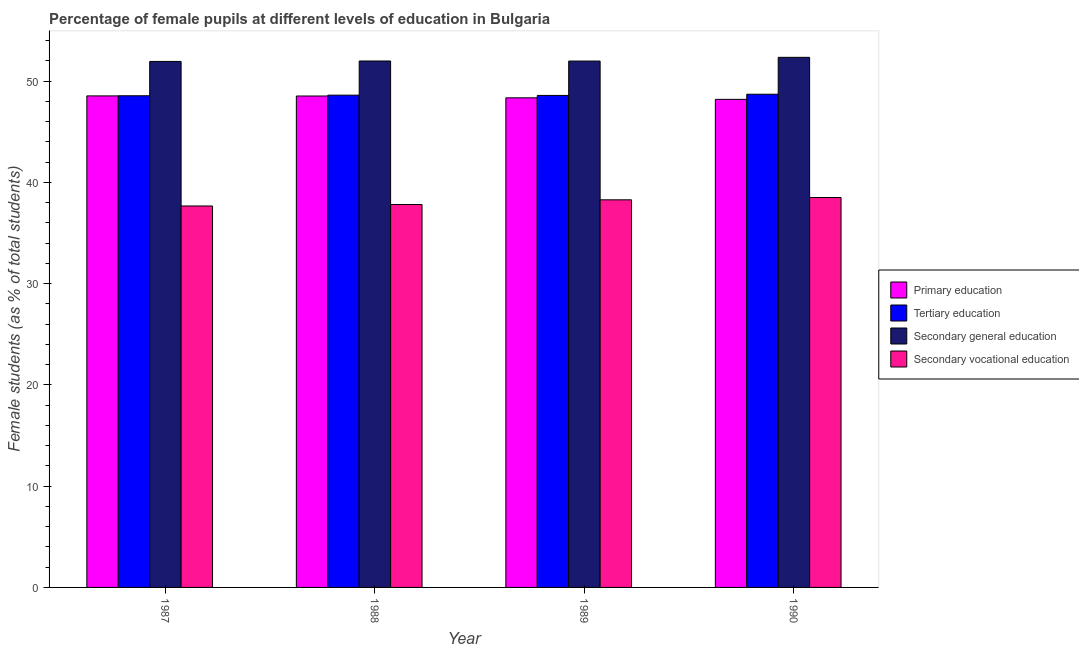How many different coloured bars are there?
Provide a succinct answer. 4. How many groups of bars are there?
Your response must be concise. 4. Are the number of bars per tick equal to the number of legend labels?
Your answer should be compact. Yes. How many bars are there on the 1st tick from the left?
Keep it short and to the point. 4. What is the percentage of female students in tertiary education in 1989?
Your answer should be compact. 48.58. Across all years, what is the maximum percentage of female students in secondary vocational education?
Offer a very short reply. 38.5. Across all years, what is the minimum percentage of female students in tertiary education?
Ensure brevity in your answer.  48.55. In which year was the percentage of female students in tertiary education maximum?
Your answer should be compact. 1990. What is the total percentage of female students in primary education in the graph?
Keep it short and to the point. 193.59. What is the difference between the percentage of female students in primary education in 1987 and that in 1990?
Provide a succinct answer. 0.34. What is the difference between the percentage of female students in tertiary education in 1990 and the percentage of female students in secondary vocational education in 1987?
Your answer should be compact. 0.15. What is the average percentage of female students in secondary education per year?
Your response must be concise. 52.06. In how many years, is the percentage of female students in secondary education greater than 2 %?
Your answer should be compact. 4. What is the ratio of the percentage of female students in tertiary education in 1989 to that in 1990?
Your response must be concise. 1. Is the percentage of female students in tertiary education in 1988 less than that in 1989?
Your answer should be compact. No. Is the difference between the percentage of female students in secondary vocational education in 1989 and 1990 greater than the difference between the percentage of female students in primary education in 1989 and 1990?
Ensure brevity in your answer.  No. What is the difference between the highest and the second highest percentage of female students in primary education?
Your answer should be very brief. 0.01. What is the difference between the highest and the lowest percentage of female students in secondary vocational education?
Make the answer very short. 0.84. Is the sum of the percentage of female students in primary education in 1988 and 1990 greater than the maximum percentage of female students in tertiary education across all years?
Offer a very short reply. Yes. Is it the case that in every year, the sum of the percentage of female students in primary education and percentage of female students in secondary vocational education is greater than the sum of percentage of female students in secondary education and percentage of female students in tertiary education?
Provide a succinct answer. Yes. What does the 1st bar from the left in 1988 represents?
Ensure brevity in your answer.  Primary education. What does the 2nd bar from the right in 1990 represents?
Your answer should be very brief. Secondary general education. How many years are there in the graph?
Provide a short and direct response. 4. Does the graph contain any zero values?
Ensure brevity in your answer.  No. Does the graph contain grids?
Offer a very short reply. No. Where does the legend appear in the graph?
Provide a succinct answer. Center right. How are the legend labels stacked?
Ensure brevity in your answer.  Vertical. What is the title of the graph?
Provide a short and direct response. Percentage of female pupils at different levels of education in Bulgaria. What is the label or title of the Y-axis?
Keep it short and to the point. Female students (as % of total students). What is the Female students (as % of total students) of Primary education in 1987?
Keep it short and to the point. 48.53. What is the Female students (as % of total students) in Tertiary education in 1987?
Ensure brevity in your answer.  48.55. What is the Female students (as % of total students) in Secondary general education in 1987?
Provide a succinct answer. 51.94. What is the Female students (as % of total students) in Secondary vocational education in 1987?
Ensure brevity in your answer.  37.66. What is the Female students (as % of total students) of Primary education in 1988?
Your response must be concise. 48.52. What is the Female students (as % of total students) in Tertiary education in 1988?
Make the answer very short. 48.6. What is the Female students (as % of total students) of Secondary general education in 1988?
Offer a very short reply. 51.98. What is the Female students (as % of total students) in Secondary vocational education in 1988?
Your response must be concise. 37.81. What is the Female students (as % of total students) of Primary education in 1989?
Offer a very short reply. 48.34. What is the Female students (as % of total students) of Tertiary education in 1989?
Make the answer very short. 48.58. What is the Female students (as % of total students) in Secondary general education in 1989?
Provide a short and direct response. 51.97. What is the Female students (as % of total students) in Secondary vocational education in 1989?
Offer a terse response. 38.27. What is the Female students (as % of total students) in Primary education in 1990?
Make the answer very short. 48.19. What is the Female students (as % of total students) in Tertiary education in 1990?
Keep it short and to the point. 48.7. What is the Female students (as % of total students) of Secondary general education in 1990?
Keep it short and to the point. 52.34. What is the Female students (as % of total students) in Secondary vocational education in 1990?
Your answer should be compact. 38.5. Across all years, what is the maximum Female students (as % of total students) of Primary education?
Provide a succinct answer. 48.53. Across all years, what is the maximum Female students (as % of total students) in Tertiary education?
Your response must be concise. 48.7. Across all years, what is the maximum Female students (as % of total students) of Secondary general education?
Your answer should be compact. 52.34. Across all years, what is the maximum Female students (as % of total students) of Secondary vocational education?
Your response must be concise. 38.5. Across all years, what is the minimum Female students (as % of total students) of Primary education?
Provide a short and direct response. 48.19. Across all years, what is the minimum Female students (as % of total students) of Tertiary education?
Provide a short and direct response. 48.55. Across all years, what is the minimum Female students (as % of total students) of Secondary general education?
Your answer should be compact. 51.94. Across all years, what is the minimum Female students (as % of total students) in Secondary vocational education?
Offer a terse response. 37.66. What is the total Female students (as % of total students) of Primary education in the graph?
Offer a very short reply. 193.59. What is the total Female students (as % of total students) in Tertiary education in the graph?
Offer a terse response. 194.43. What is the total Female students (as % of total students) of Secondary general education in the graph?
Give a very brief answer. 208.23. What is the total Female students (as % of total students) in Secondary vocational education in the graph?
Your response must be concise. 152.24. What is the difference between the Female students (as % of total students) of Primary education in 1987 and that in 1988?
Give a very brief answer. 0.01. What is the difference between the Female students (as % of total students) in Tertiary education in 1987 and that in 1988?
Keep it short and to the point. -0.06. What is the difference between the Female students (as % of total students) of Secondary general education in 1987 and that in 1988?
Offer a terse response. -0.04. What is the difference between the Female students (as % of total students) in Secondary vocational education in 1987 and that in 1988?
Offer a terse response. -0.15. What is the difference between the Female students (as % of total students) in Primary education in 1987 and that in 1989?
Your answer should be compact. 0.19. What is the difference between the Female students (as % of total students) in Tertiary education in 1987 and that in 1989?
Your response must be concise. -0.03. What is the difference between the Female students (as % of total students) in Secondary general education in 1987 and that in 1989?
Keep it short and to the point. -0.04. What is the difference between the Female students (as % of total students) in Secondary vocational education in 1987 and that in 1989?
Ensure brevity in your answer.  -0.61. What is the difference between the Female students (as % of total students) of Primary education in 1987 and that in 1990?
Your answer should be compact. 0.34. What is the difference between the Female students (as % of total students) of Tertiary education in 1987 and that in 1990?
Keep it short and to the point. -0.15. What is the difference between the Female students (as % of total students) in Secondary general education in 1987 and that in 1990?
Your answer should be very brief. -0.4. What is the difference between the Female students (as % of total students) of Secondary vocational education in 1987 and that in 1990?
Offer a very short reply. -0.84. What is the difference between the Female students (as % of total students) in Primary education in 1988 and that in 1989?
Make the answer very short. 0.18. What is the difference between the Female students (as % of total students) in Tertiary education in 1988 and that in 1989?
Your response must be concise. 0.03. What is the difference between the Female students (as % of total students) in Secondary general education in 1988 and that in 1989?
Offer a very short reply. 0.01. What is the difference between the Female students (as % of total students) in Secondary vocational education in 1988 and that in 1989?
Offer a terse response. -0.46. What is the difference between the Female students (as % of total students) of Primary education in 1988 and that in 1990?
Give a very brief answer. 0.33. What is the difference between the Female students (as % of total students) of Tertiary education in 1988 and that in 1990?
Provide a succinct answer. -0.09. What is the difference between the Female students (as % of total students) in Secondary general education in 1988 and that in 1990?
Ensure brevity in your answer.  -0.36. What is the difference between the Female students (as % of total students) of Secondary vocational education in 1988 and that in 1990?
Give a very brief answer. -0.69. What is the difference between the Female students (as % of total students) in Primary education in 1989 and that in 1990?
Provide a succinct answer. 0.15. What is the difference between the Female students (as % of total students) of Tertiary education in 1989 and that in 1990?
Keep it short and to the point. -0.12. What is the difference between the Female students (as % of total students) of Secondary general education in 1989 and that in 1990?
Your response must be concise. -0.37. What is the difference between the Female students (as % of total students) in Secondary vocational education in 1989 and that in 1990?
Provide a succinct answer. -0.23. What is the difference between the Female students (as % of total students) in Primary education in 1987 and the Female students (as % of total students) in Tertiary education in 1988?
Provide a succinct answer. -0.07. What is the difference between the Female students (as % of total students) in Primary education in 1987 and the Female students (as % of total students) in Secondary general education in 1988?
Offer a very short reply. -3.45. What is the difference between the Female students (as % of total students) of Primary education in 1987 and the Female students (as % of total students) of Secondary vocational education in 1988?
Your answer should be compact. 10.72. What is the difference between the Female students (as % of total students) of Tertiary education in 1987 and the Female students (as % of total students) of Secondary general education in 1988?
Keep it short and to the point. -3.43. What is the difference between the Female students (as % of total students) in Tertiary education in 1987 and the Female students (as % of total students) in Secondary vocational education in 1988?
Offer a very short reply. 10.74. What is the difference between the Female students (as % of total students) of Secondary general education in 1987 and the Female students (as % of total students) of Secondary vocational education in 1988?
Your answer should be compact. 14.13. What is the difference between the Female students (as % of total students) of Primary education in 1987 and the Female students (as % of total students) of Tertiary education in 1989?
Ensure brevity in your answer.  -0.05. What is the difference between the Female students (as % of total students) of Primary education in 1987 and the Female students (as % of total students) of Secondary general education in 1989?
Your response must be concise. -3.44. What is the difference between the Female students (as % of total students) in Primary education in 1987 and the Female students (as % of total students) in Secondary vocational education in 1989?
Your answer should be very brief. 10.26. What is the difference between the Female students (as % of total students) of Tertiary education in 1987 and the Female students (as % of total students) of Secondary general education in 1989?
Make the answer very short. -3.43. What is the difference between the Female students (as % of total students) in Tertiary education in 1987 and the Female students (as % of total students) in Secondary vocational education in 1989?
Ensure brevity in your answer.  10.27. What is the difference between the Female students (as % of total students) in Secondary general education in 1987 and the Female students (as % of total students) in Secondary vocational education in 1989?
Give a very brief answer. 13.66. What is the difference between the Female students (as % of total students) in Primary education in 1987 and the Female students (as % of total students) in Tertiary education in 1990?
Provide a short and direct response. -0.16. What is the difference between the Female students (as % of total students) of Primary education in 1987 and the Female students (as % of total students) of Secondary general education in 1990?
Provide a succinct answer. -3.81. What is the difference between the Female students (as % of total students) of Primary education in 1987 and the Female students (as % of total students) of Secondary vocational education in 1990?
Your answer should be compact. 10.03. What is the difference between the Female students (as % of total students) of Tertiary education in 1987 and the Female students (as % of total students) of Secondary general education in 1990?
Give a very brief answer. -3.79. What is the difference between the Female students (as % of total students) of Tertiary education in 1987 and the Female students (as % of total students) of Secondary vocational education in 1990?
Offer a terse response. 10.05. What is the difference between the Female students (as % of total students) of Secondary general education in 1987 and the Female students (as % of total students) of Secondary vocational education in 1990?
Your answer should be compact. 13.44. What is the difference between the Female students (as % of total students) of Primary education in 1988 and the Female students (as % of total students) of Tertiary education in 1989?
Make the answer very short. -0.06. What is the difference between the Female students (as % of total students) in Primary education in 1988 and the Female students (as % of total students) in Secondary general education in 1989?
Offer a very short reply. -3.45. What is the difference between the Female students (as % of total students) in Primary education in 1988 and the Female students (as % of total students) in Secondary vocational education in 1989?
Give a very brief answer. 10.25. What is the difference between the Female students (as % of total students) of Tertiary education in 1988 and the Female students (as % of total students) of Secondary general education in 1989?
Keep it short and to the point. -3.37. What is the difference between the Female students (as % of total students) in Tertiary education in 1988 and the Female students (as % of total students) in Secondary vocational education in 1989?
Your answer should be very brief. 10.33. What is the difference between the Female students (as % of total students) of Secondary general education in 1988 and the Female students (as % of total students) of Secondary vocational education in 1989?
Your response must be concise. 13.71. What is the difference between the Female students (as % of total students) of Primary education in 1988 and the Female students (as % of total students) of Tertiary education in 1990?
Make the answer very short. -0.18. What is the difference between the Female students (as % of total students) in Primary education in 1988 and the Female students (as % of total students) in Secondary general education in 1990?
Provide a succinct answer. -3.82. What is the difference between the Female students (as % of total students) of Primary education in 1988 and the Female students (as % of total students) of Secondary vocational education in 1990?
Your answer should be compact. 10.02. What is the difference between the Female students (as % of total students) in Tertiary education in 1988 and the Female students (as % of total students) in Secondary general education in 1990?
Offer a terse response. -3.74. What is the difference between the Female students (as % of total students) of Tertiary education in 1988 and the Female students (as % of total students) of Secondary vocational education in 1990?
Keep it short and to the point. 10.1. What is the difference between the Female students (as % of total students) of Secondary general education in 1988 and the Female students (as % of total students) of Secondary vocational education in 1990?
Your response must be concise. 13.48. What is the difference between the Female students (as % of total students) of Primary education in 1989 and the Female students (as % of total students) of Tertiary education in 1990?
Your answer should be very brief. -0.35. What is the difference between the Female students (as % of total students) of Primary education in 1989 and the Female students (as % of total students) of Secondary general education in 1990?
Keep it short and to the point. -4. What is the difference between the Female students (as % of total students) of Primary education in 1989 and the Female students (as % of total students) of Secondary vocational education in 1990?
Your response must be concise. 9.84. What is the difference between the Female students (as % of total students) in Tertiary education in 1989 and the Female students (as % of total students) in Secondary general education in 1990?
Give a very brief answer. -3.76. What is the difference between the Female students (as % of total students) in Tertiary education in 1989 and the Female students (as % of total students) in Secondary vocational education in 1990?
Your response must be concise. 10.08. What is the difference between the Female students (as % of total students) of Secondary general education in 1989 and the Female students (as % of total students) of Secondary vocational education in 1990?
Provide a succinct answer. 13.47. What is the average Female students (as % of total students) in Primary education per year?
Your response must be concise. 48.4. What is the average Female students (as % of total students) in Tertiary education per year?
Provide a short and direct response. 48.61. What is the average Female students (as % of total students) in Secondary general education per year?
Your answer should be compact. 52.06. What is the average Female students (as % of total students) in Secondary vocational education per year?
Provide a succinct answer. 38.06. In the year 1987, what is the difference between the Female students (as % of total students) in Primary education and Female students (as % of total students) in Tertiary education?
Provide a succinct answer. -0.01. In the year 1987, what is the difference between the Female students (as % of total students) of Primary education and Female students (as % of total students) of Secondary general education?
Ensure brevity in your answer.  -3.4. In the year 1987, what is the difference between the Female students (as % of total students) in Primary education and Female students (as % of total students) in Secondary vocational education?
Make the answer very short. 10.87. In the year 1987, what is the difference between the Female students (as % of total students) of Tertiary education and Female students (as % of total students) of Secondary general education?
Your answer should be very brief. -3.39. In the year 1987, what is the difference between the Female students (as % of total students) in Tertiary education and Female students (as % of total students) in Secondary vocational education?
Offer a very short reply. 10.88. In the year 1987, what is the difference between the Female students (as % of total students) in Secondary general education and Female students (as % of total students) in Secondary vocational education?
Make the answer very short. 14.27. In the year 1988, what is the difference between the Female students (as % of total students) of Primary education and Female students (as % of total students) of Tertiary education?
Your response must be concise. -0.08. In the year 1988, what is the difference between the Female students (as % of total students) in Primary education and Female students (as % of total students) in Secondary general education?
Provide a succinct answer. -3.46. In the year 1988, what is the difference between the Female students (as % of total students) in Primary education and Female students (as % of total students) in Secondary vocational education?
Keep it short and to the point. 10.71. In the year 1988, what is the difference between the Female students (as % of total students) in Tertiary education and Female students (as % of total students) in Secondary general education?
Your response must be concise. -3.37. In the year 1988, what is the difference between the Female students (as % of total students) of Tertiary education and Female students (as % of total students) of Secondary vocational education?
Offer a terse response. 10.79. In the year 1988, what is the difference between the Female students (as % of total students) in Secondary general education and Female students (as % of total students) in Secondary vocational education?
Offer a very short reply. 14.17. In the year 1989, what is the difference between the Female students (as % of total students) in Primary education and Female students (as % of total students) in Tertiary education?
Offer a very short reply. -0.24. In the year 1989, what is the difference between the Female students (as % of total students) of Primary education and Female students (as % of total students) of Secondary general education?
Your answer should be compact. -3.63. In the year 1989, what is the difference between the Female students (as % of total students) of Primary education and Female students (as % of total students) of Secondary vocational education?
Make the answer very short. 10.07. In the year 1989, what is the difference between the Female students (as % of total students) of Tertiary education and Female students (as % of total students) of Secondary general education?
Offer a terse response. -3.39. In the year 1989, what is the difference between the Female students (as % of total students) of Tertiary education and Female students (as % of total students) of Secondary vocational education?
Provide a short and direct response. 10.31. In the year 1989, what is the difference between the Female students (as % of total students) of Secondary general education and Female students (as % of total students) of Secondary vocational education?
Your response must be concise. 13.7. In the year 1990, what is the difference between the Female students (as % of total students) of Primary education and Female students (as % of total students) of Tertiary education?
Your response must be concise. -0.51. In the year 1990, what is the difference between the Female students (as % of total students) of Primary education and Female students (as % of total students) of Secondary general education?
Keep it short and to the point. -4.15. In the year 1990, what is the difference between the Female students (as % of total students) of Primary education and Female students (as % of total students) of Secondary vocational education?
Offer a very short reply. 9.69. In the year 1990, what is the difference between the Female students (as % of total students) of Tertiary education and Female students (as % of total students) of Secondary general education?
Offer a very short reply. -3.64. In the year 1990, what is the difference between the Female students (as % of total students) in Tertiary education and Female students (as % of total students) in Secondary vocational education?
Offer a terse response. 10.2. In the year 1990, what is the difference between the Female students (as % of total students) of Secondary general education and Female students (as % of total students) of Secondary vocational education?
Offer a terse response. 13.84. What is the ratio of the Female students (as % of total students) in Secondary general education in 1987 to that in 1988?
Keep it short and to the point. 1. What is the ratio of the Female students (as % of total students) in Secondary vocational education in 1987 to that in 1988?
Provide a succinct answer. 1. What is the ratio of the Female students (as % of total students) of Primary education in 1987 to that in 1989?
Provide a short and direct response. 1. What is the ratio of the Female students (as % of total students) in Secondary general education in 1987 to that in 1989?
Offer a very short reply. 1. What is the ratio of the Female students (as % of total students) of Secondary vocational education in 1987 to that in 1989?
Your answer should be compact. 0.98. What is the ratio of the Female students (as % of total students) in Primary education in 1987 to that in 1990?
Your response must be concise. 1.01. What is the ratio of the Female students (as % of total students) in Secondary vocational education in 1987 to that in 1990?
Give a very brief answer. 0.98. What is the ratio of the Female students (as % of total students) of Tertiary education in 1988 to that in 1990?
Provide a short and direct response. 1. What is the ratio of the Female students (as % of total students) in Secondary vocational education in 1988 to that in 1990?
Keep it short and to the point. 0.98. What is the ratio of the Female students (as % of total students) in Secondary general education in 1989 to that in 1990?
Keep it short and to the point. 0.99. What is the difference between the highest and the second highest Female students (as % of total students) in Primary education?
Provide a short and direct response. 0.01. What is the difference between the highest and the second highest Female students (as % of total students) in Tertiary education?
Your response must be concise. 0.09. What is the difference between the highest and the second highest Female students (as % of total students) in Secondary general education?
Ensure brevity in your answer.  0.36. What is the difference between the highest and the second highest Female students (as % of total students) in Secondary vocational education?
Offer a very short reply. 0.23. What is the difference between the highest and the lowest Female students (as % of total students) of Primary education?
Provide a short and direct response. 0.34. What is the difference between the highest and the lowest Female students (as % of total students) of Tertiary education?
Your answer should be very brief. 0.15. What is the difference between the highest and the lowest Female students (as % of total students) of Secondary general education?
Your answer should be compact. 0.4. What is the difference between the highest and the lowest Female students (as % of total students) of Secondary vocational education?
Keep it short and to the point. 0.84. 